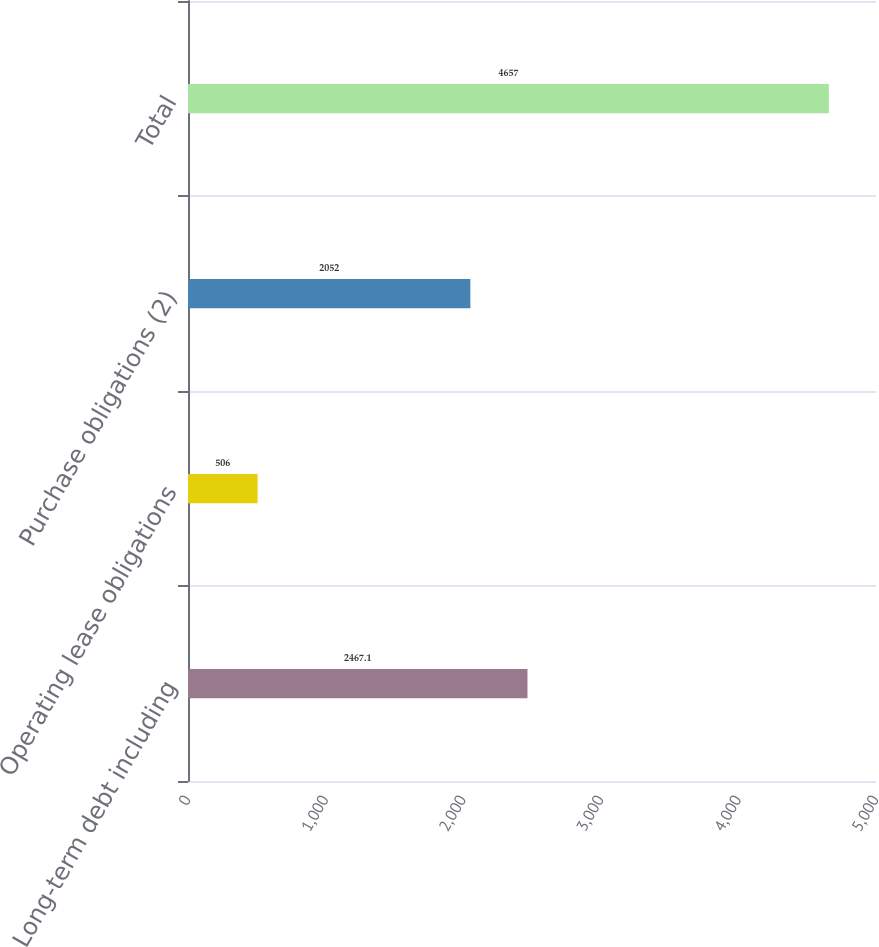<chart> <loc_0><loc_0><loc_500><loc_500><bar_chart><fcel>Long-term debt including<fcel>Operating lease obligations<fcel>Purchase obligations (2)<fcel>Total<nl><fcel>2467.1<fcel>506<fcel>2052<fcel>4657<nl></chart> 